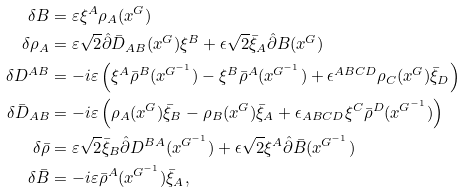<formula> <loc_0><loc_0><loc_500><loc_500>\delta B & = \varepsilon \xi ^ { A } \rho _ { A } ( x ^ { G } ) \\ \delta \rho _ { A } & = \varepsilon \sqrt { 2 } \hat { \partial } \bar { D } _ { A B } ( x ^ { G } ) \xi ^ { B } + \epsilon \sqrt { 2 } \bar { \xi } _ { A } \hat { \partial } B ( x ^ { G } ) \\ \delta D ^ { A B } & = - i \varepsilon \left ( \xi ^ { A } \bar { \rho } ^ { B } ( x ^ { G ^ { - 1 } } ) - \xi ^ { B } \bar { \rho } ^ { A } ( x ^ { G ^ { - 1 } } ) + \epsilon ^ { A B C D } \rho _ { C } ( x ^ { G } ) \bar { \xi } _ { D } \right ) \\ \delta \bar { D } _ { A B } & = - i \varepsilon \left ( \rho _ { A } ( x ^ { G } ) \bar { \xi } _ { B } - \rho _ { B } ( x ^ { G } ) \bar { \xi } _ { A } + \epsilon _ { A B C D } \xi ^ { C } \bar { \rho } ^ { D } ( x ^ { G ^ { - 1 } } ) \right ) \\ \delta \bar { \rho } & = \varepsilon \sqrt { 2 } \bar { \xi } _ { B } \hat { \partial } D ^ { B A } ( x ^ { G ^ { - 1 } } ) + \epsilon \sqrt { 2 } \xi ^ { A } \hat { \partial } \bar { B } ( x ^ { G ^ { - 1 } } ) \\ \delta \bar { B } & = - i \varepsilon \bar { \rho } ^ { A } ( x ^ { G ^ { - 1 } } ) \bar { \xi } _ { A } ,</formula> 